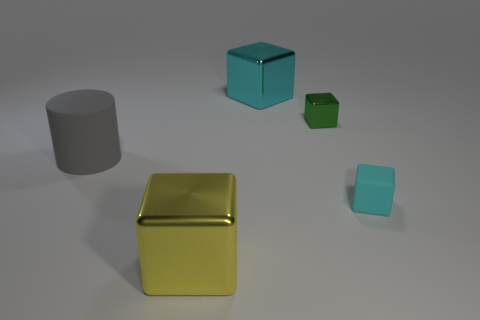How many other big metal objects are the same shape as the yellow metallic object? 1 